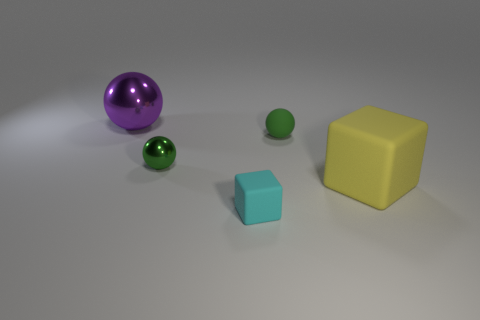What number of metal spheres have the same color as the tiny shiny object?
Provide a short and direct response. 0. There is a big thing that is to the right of the large purple ball; are there any large blocks in front of it?
Your response must be concise. No. What number of things are to the right of the purple shiny ball and behind the yellow matte block?
Offer a very short reply. 2. How many green objects have the same material as the cyan cube?
Provide a short and direct response. 1. How big is the rubber object behind the rubber block on the right side of the cyan matte block?
Your response must be concise. Small. Is there a small cyan matte object that has the same shape as the purple shiny thing?
Give a very brief answer. No. Do the rubber block that is behind the cyan matte thing and the rubber cube to the left of the large rubber thing have the same size?
Your answer should be compact. No. Are there fewer small green spheres that are to the left of the big metal ball than large purple spheres that are in front of the cyan cube?
Offer a very short reply. No. There is a object that is the same color as the small shiny ball; what is its material?
Offer a very short reply. Rubber. There is a rubber thing that is in front of the large matte cube; what is its color?
Ensure brevity in your answer.  Cyan. 